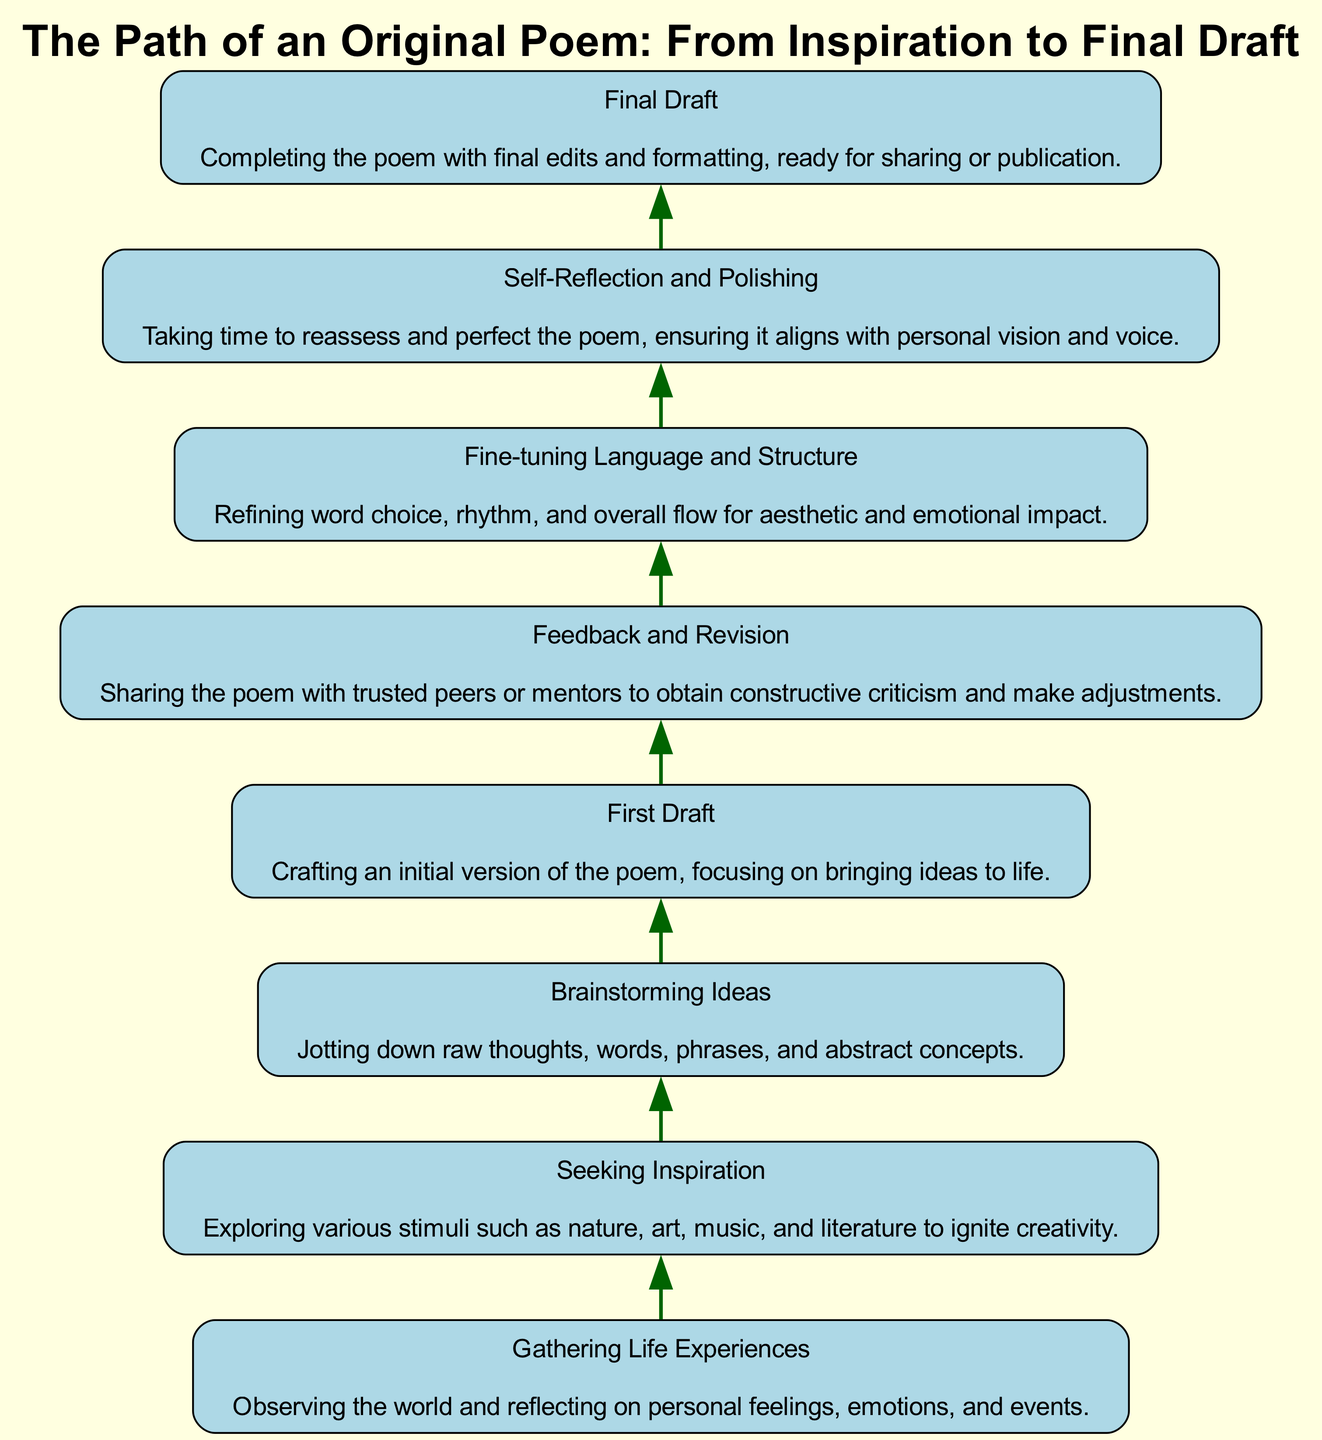What is the first step in the diagram? The diagram shows that the first step at the bottom is "Gathering Life Experiences." This is determined by starting at the lowest node and looking for the first labeled step in the flow.
Answer: Gathering Life Experiences How many steps are there in total? By counting the total number of nodes listed in the diagram, we find that there are eight distinct steps in the process of creating an original poem.
Answer: Eight What comes after "Brainstorming Ideas"? The flow of the diagram indicates that the step immediately following "Brainstorming Ideas" is "First Draft." This can be identified by looking at the connection from the "Brainstorming Ideas" node upwards.
Answer: First Draft Which step involves sharing the poem for feedback? The step that involves sharing the poem for feedback is "Feedback and Revision." This can be found by identifying the node focused on obtaining constructive criticism, which is right after the "First Draft."
Answer: Feedback and Revision What is the final step in the process? The final step in the diagram, located at the top, is "Final Draft," indicating the completed version of the poem. This can be confirmed by tracing the flow upwards to the last node.
Answer: Final Draft What is the relationship between "Fine-tuning Language and Structure" and "Self-Reflection and Polishing"? The relationship is sequential; "Fine-tuning Language and Structure" directly precedes "Self-Reflection and Polishing" in the flow. This is determined by the upward connection between these two steps in the diagram.
Answer: Sequential How many steps precede "Final Draft"? There are six steps that come before "Final Draft." By counting the nodes from the first step up to, but not including, the "Final Draft" node, we find there are six distinct steps.
Answer: Six Which step focuses on reassessing the poem? The step that focuses on reassessing the poem is "Self-Reflection and Polishing." This is identified by locating the description that emphasizes taking time to perfect the poem, which occurs just before the final step.
Answer: Self-Reflection and Polishing 